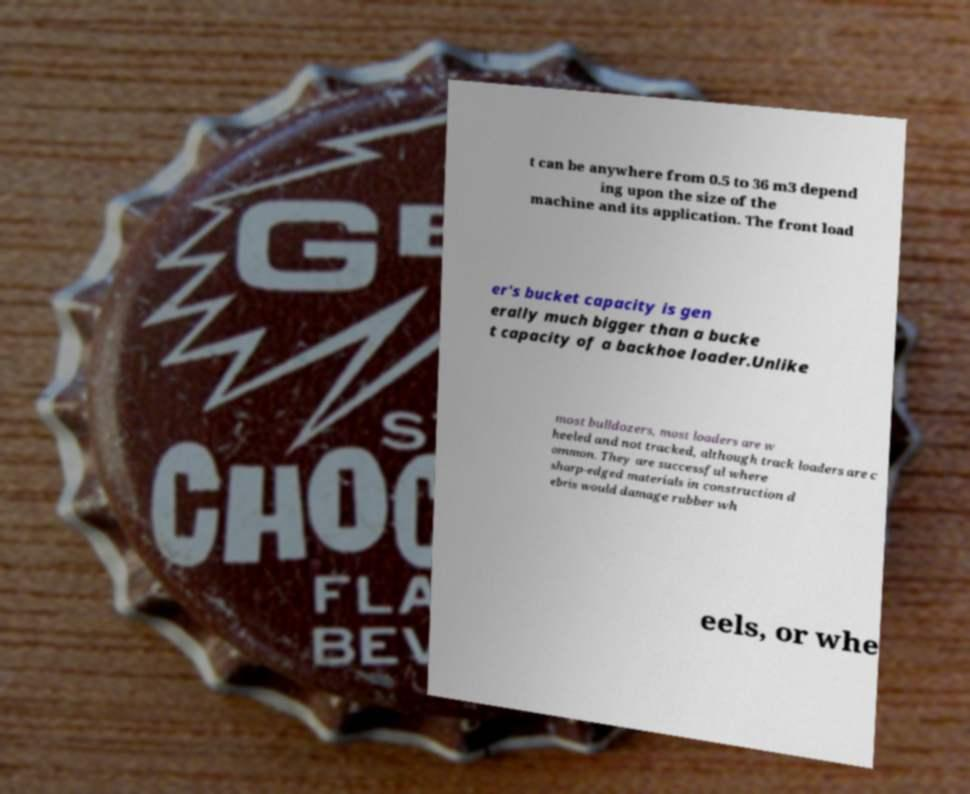Can you accurately transcribe the text from the provided image for me? t can be anywhere from 0.5 to 36 m3 depend ing upon the size of the machine and its application. The front load er's bucket capacity is gen erally much bigger than a bucke t capacity of a backhoe loader.Unlike most bulldozers, most loaders are w heeled and not tracked, although track loaders are c ommon. They are successful where sharp-edged materials in construction d ebris would damage rubber wh eels, or whe 